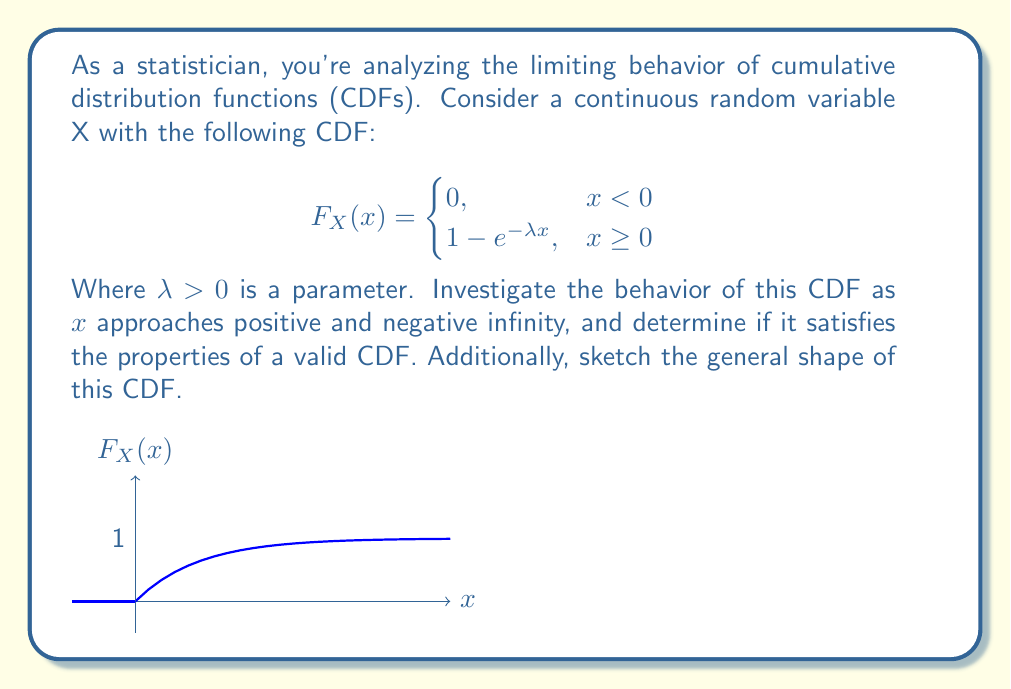Could you help me with this problem? To investigate the behavior of the CDF, we'll examine its limits as x approaches positive and negative infinity, and check its properties:

1. Limit as x approaches negative infinity:
   $$\lim_{x \to -\infty} F_X(x) = \lim_{x \to -\infty} 0 = 0$$

2. Limit as x approaches positive infinity:
   $$\lim_{x \to \infty} F_X(x) = \lim_{x \to \infty} (1 - e^{-\lambda x}) = 1 - \lim_{x \to \infty} e^{-\lambda x} = 1 - 0 = 1$$

3. Continuity:
   The function is continuous at x = 0 because:
   $$\lim_{x \to 0^-} F_X(x) = 0$$
   $$\lim_{x \to 0^+} F_X(x) = 1 - e^{-\lambda \cdot 0} = 1 - 1 = 0$$
   $$F_X(0) = 0$$

4. Monotonicity:
   For x ≥ 0, the derivative is positive:
   $$\frac{d}{dx}F_X(x) = \lambda e^{-\lambda x} > 0$$
   This means the function is strictly increasing for x ≥ 0.

5. Right-continuity:
   The function is continuous for all x, which implies it's right-continuous.

These properties satisfy the requirements for a valid CDF:
- It approaches 0 as x approaches negative infinity
- It approaches 1 as x approaches positive infinity
- It is non-decreasing
- It is right-continuous

The sketch provided in the question accurately represents the shape of this CDF.
Answer: The CDF satisfies all properties of a valid cumulative distribution function, with $\lim_{x \to -\infty} F_X(x) = 0$ and $\lim_{x \to \infty} F_X(x) = 1$. 